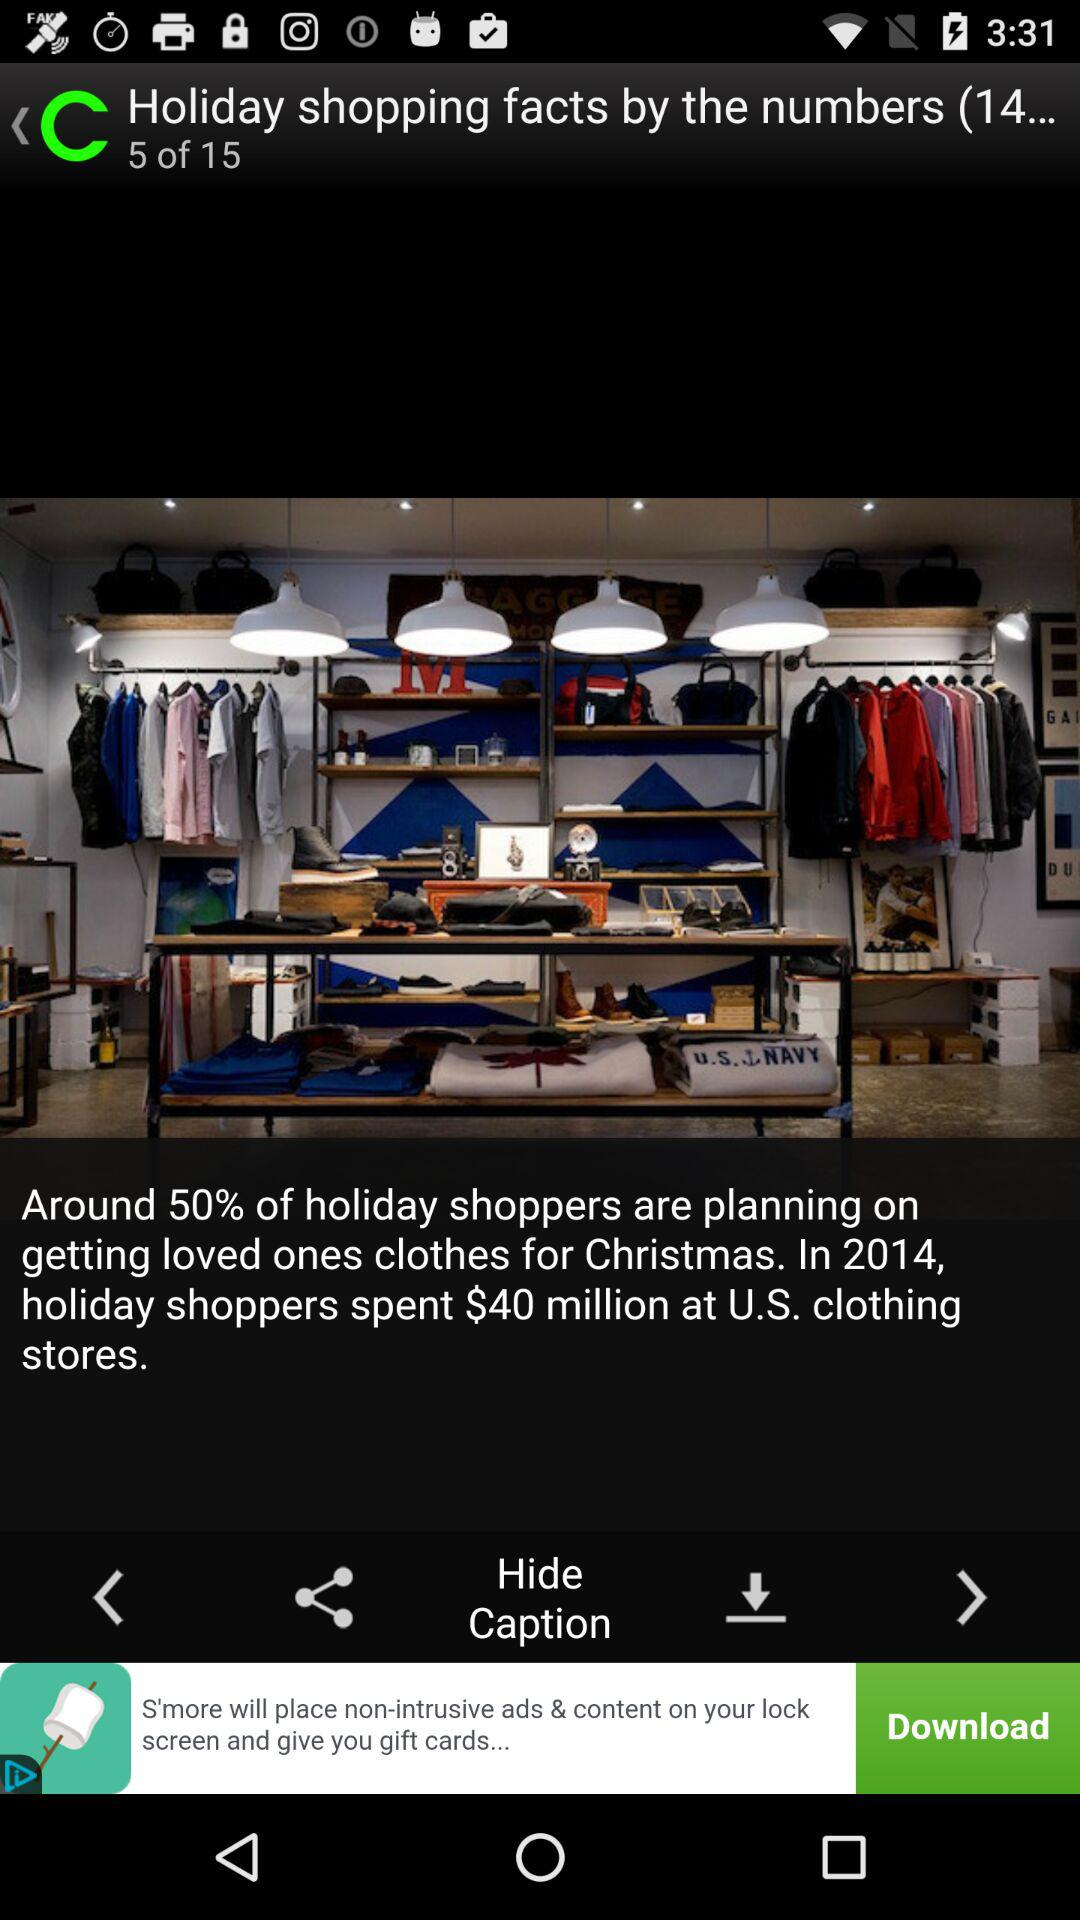How many images in total are there? There are 15 images. 